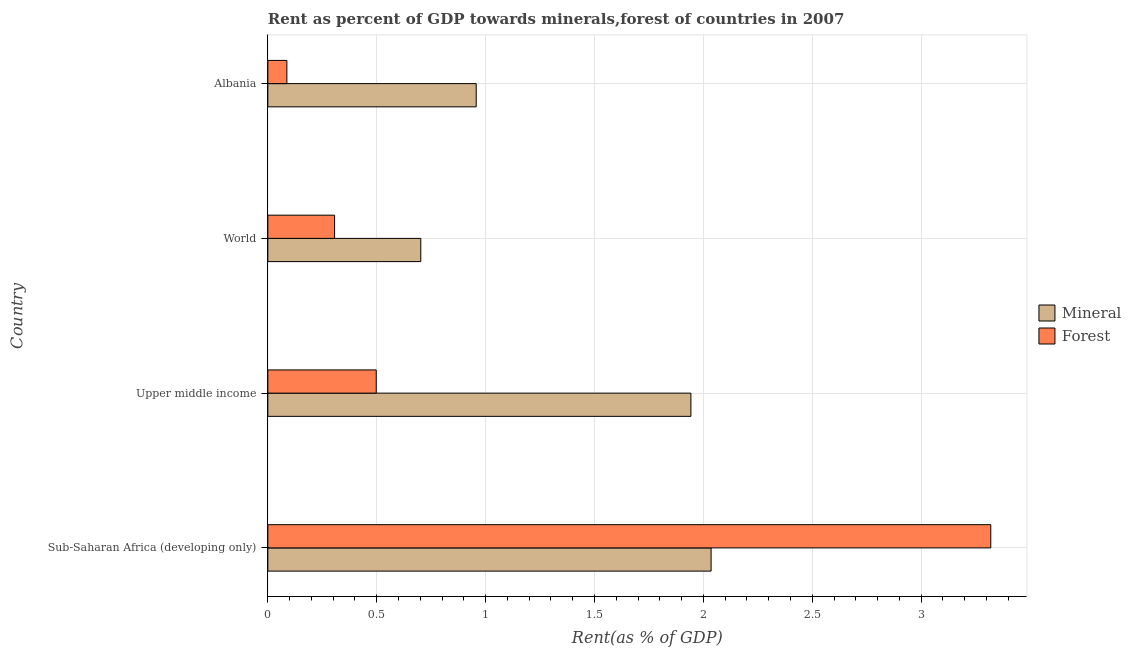How many different coloured bars are there?
Your answer should be compact. 2. How many groups of bars are there?
Your response must be concise. 4. How many bars are there on the 3rd tick from the top?
Provide a succinct answer. 2. How many bars are there on the 2nd tick from the bottom?
Your answer should be very brief. 2. What is the label of the 3rd group of bars from the top?
Give a very brief answer. Upper middle income. What is the forest rent in World?
Your answer should be very brief. 0.31. Across all countries, what is the maximum mineral rent?
Ensure brevity in your answer.  2.04. Across all countries, what is the minimum forest rent?
Provide a succinct answer. 0.09. In which country was the forest rent maximum?
Provide a succinct answer. Sub-Saharan Africa (developing only). In which country was the forest rent minimum?
Offer a terse response. Albania. What is the total mineral rent in the graph?
Keep it short and to the point. 5.64. What is the difference between the forest rent in Sub-Saharan Africa (developing only) and that in Upper middle income?
Make the answer very short. 2.82. What is the difference between the mineral rent in World and the forest rent in Upper middle income?
Make the answer very short. 0.2. What is the average forest rent per country?
Offer a terse response. 1.05. What is the difference between the forest rent and mineral rent in World?
Provide a short and direct response. -0.4. In how many countries, is the forest rent greater than 1.7 %?
Make the answer very short. 1. What is the ratio of the forest rent in Albania to that in World?
Your answer should be compact. 0.28. What is the difference between the highest and the second highest forest rent?
Make the answer very short. 2.82. What is the difference between the highest and the lowest forest rent?
Your answer should be compact. 3.23. What does the 1st bar from the top in Albania represents?
Offer a terse response. Forest. What does the 1st bar from the bottom in Upper middle income represents?
Offer a terse response. Mineral. How many bars are there?
Your answer should be compact. 8. Are all the bars in the graph horizontal?
Give a very brief answer. Yes. Are the values on the major ticks of X-axis written in scientific E-notation?
Ensure brevity in your answer.  No. Does the graph contain any zero values?
Provide a succinct answer. No. Does the graph contain grids?
Make the answer very short. Yes. How are the legend labels stacked?
Offer a terse response. Vertical. What is the title of the graph?
Your response must be concise. Rent as percent of GDP towards minerals,forest of countries in 2007. Does "Under five" appear as one of the legend labels in the graph?
Provide a succinct answer. No. What is the label or title of the X-axis?
Keep it short and to the point. Rent(as % of GDP). What is the label or title of the Y-axis?
Your answer should be compact. Country. What is the Rent(as % of GDP) of Mineral in Sub-Saharan Africa (developing only)?
Give a very brief answer. 2.04. What is the Rent(as % of GDP) in Forest in Sub-Saharan Africa (developing only)?
Make the answer very short. 3.32. What is the Rent(as % of GDP) of Mineral in Upper middle income?
Offer a very short reply. 1.94. What is the Rent(as % of GDP) in Forest in Upper middle income?
Provide a short and direct response. 0.5. What is the Rent(as % of GDP) of Mineral in World?
Your answer should be compact. 0.7. What is the Rent(as % of GDP) in Forest in World?
Your response must be concise. 0.31. What is the Rent(as % of GDP) in Mineral in Albania?
Ensure brevity in your answer.  0.96. What is the Rent(as % of GDP) in Forest in Albania?
Make the answer very short. 0.09. Across all countries, what is the maximum Rent(as % of GDP) of Mineral?
Keep it short and to the point. 2.04. Across all countries, what is the maximum Rent(as % of GDP) of Forest?
Give a very brief answer. 3.32. Across all countries, what is the minimum Rent(as % of GDP) of Mineral?
Keep it short and to the point. 0.7. Across all countries, what is the minimum Rent(as % of GDP) in Forest?
Keep it short and to the point. 0.09. What is the total Rent(as % of GDP) in Mineral in the graph?
Provide a succinct answer. 5.64. What is the total Rent(as % of GDP) in Forest in the graph?
Offer a terse response. 4.21. What is the difference between the Rent(as % of GDP) in Mineral in Sub-Saharan Africa (developing only) and that in Upper middle income?
Provide a succinct answer. 0.09. What is the difference between the Rent(as % of GDP) in Forest in Sub-Saharan Africa (developing only) and that in Upper middle income?
Provide a short and direct response. 2.82. What is the difference between the Rent(as % of GDP) of Mineral in Sub-Saharan Africa (developing only) and that in World?
Offer a very short reply. 1.33. What is the difference between the Rent(as % of GDP) in Forest in Sub-Saharan Africa (developing only) and that in World?
Make the answer very short. 3.01. What is the difference between the Rent(as % of GDP) of Mineral in Sub-Saharan Africa (developing only) and that in Albania?
Provide a succinct answer. 1.08. What is the difference between the Rent(as % of GDP) in Forest in Sub-Saharan Africa (developing only) and that in Albania?
Make the answer very short. 3.23. What is the difference between the Rent(as % of GDP) in Mineral in Upper middle income and that in World?
Ensure brevity in your answer.  1.24. What is the difference between the Rent(as % of GDP) of Forest in Upper middle income and that in World?
Your response must be concise. 0.19. What is the difference between the Rent(as % of GDP) in Forest in Upper middle income and that in Albania?
Provide a succinct answer. 0.41. What is the difference between the Rent(as % of GDP) in Mineral in World and that in Albania?
Ensure brevity in your answer.  -0.25. What is the difference between the Rent(as % of GDP) in Forest in World and that in Albania?
Give a very brief answer. 0.22. What is the difference between the Rent(as % of GDP) in Mineral in Sub-Saharan Africa (developing only) and the Rent(as % of GDP) in Forest in Upper middle income?
Your answer should be very brief. 1.54. What is the difference between the Rent(as % of GDP) of Mineral in Sub-Saharan Africa (developing only) and the Rent(as % of GDP) of Forest in World?
Your answer should be compact. 1.73. What is the difference between the Rent(as % of GDP) of Mineral in Sub-Saharan Africa (developing only) and the Rent(as % of GDP) of Forest in Albania?
Ensure brevity in your answer.  1.95. What is the difference between the Rent(as % of GDP) of Mineral in Upper middle income and the Rent(as % of GDP) of Forest in World?
Provide a short and direct response. 1.64. What is the difference between the Rent(as % of GDP) of Mineral in Upper middle income and the Rent(as % of GDP) of Forest in Albania?
Your response must be concise. 1.86. What is the difference between the Rent(as % of GDP) of Mineral in World and the Rent(as % of GDP) of Forest in Albania?
Provide a succinct answer. 0.61. What is the average Rent(as % of GDP) in Mineral per country?
Provide a short and direct response. 1.41. What is the average Rent(as % of GDP) of Forest per country?
Make the answer very short. 1.05. What is the difference between the Rent(as % of GDP) in Mineral and Rent(as % of GDP) in Forest in Sub-Saharan Africa (developing only)?
Provide a short and direct response. -1.28. What is the difference between the Rent(as % of GDP) of Mineral and Rent(as % of GDP) of Forest in Upper middle income?
Offer a terse response. 1.45. What is the difference between the Rent(as % of GDP) of Mineral and Rent(as % of GDP) of Forest in World?
Keep it short and to the point. 0.4. What is the difference between the Rent(as % of GDP) of Mineral and Rent(as % of GDP) of Forest in Albania?
Provide a succinct answer. 0.87. What is the ratio of the Rent(as % of GDP) in Mineral in Sub-Saharan Africa (developing only) to that in Upper middle income?
Keep it short and to the point. 1.05. What is the ratio of the Rent(as % of GDP) of Forest in Sub-Saharan Africa (developing only) to that in Upper middle income?
Your answer should be very brief. 6.67. What is the ratio of the Rent(as % of GDP) of Mineral in Sub-Saharan Africa (developing only) to that in World?
Your answer should be compact. 2.9. What is the ratio of the Rent(as % of GDP) of Forest in Sub-Saharan Africa (developing only) to that in World?
Your response must be concise. 10.83. What is the ratio of the Rent(as % of GDP) in Mineral in Sub-Saharan Africa (developing only) to that in Albania?
Offer a terse response. 2.13. What is the ratio of the Rent(as % of GDP) in Forest in Sub-Saharan Africa (developing only) to that in Albania?
Keep it short and to the point. 38. What is the ratio of the Rent(as % of GDP) in Mineral in Upper middle income to that in World?
Keep it short and to the point. 2.77. What is the ratio of the Rent(as % of GDP) in Forest in Upper middle income to that in World?
Your answer should be very brief. 1.62. What is the ratio of the Rent(as % of GDP) of Mineral in Upper middle income to that in Albania?
Your answer should be compact. 2.03. What is the ratio of the Rent(as % of GDP) of Forest in Upper middle income to that in Albania?
Make the answer very short. 5.7. What is the ratio of the Rent(as % of GDP) of Mineral in World to that in Albania?
Offer a terse response. 0.73. What is the ratio of the Rent(as % of GDP) of Forest in World to that in Albania?
Provide a short and direct response. 3.51. What is the difference between the highest and the second highest Rent(as % of GDP) in Mineral?
Ensure brevity in your answer.  0.09. What is the difference between the highest and the second highest Rent(as % of GDP) in Forest?
Your answer should be compact. 2.82. What is the difference between the highest and the lowest Rent(as % of GDP) in Mineral?
Your answer should be compact. 1.33. What is the difference between the highest and the lowest Rent(as % of GDP) of Forest?
Ensure brevity in your answer.  3.23. 